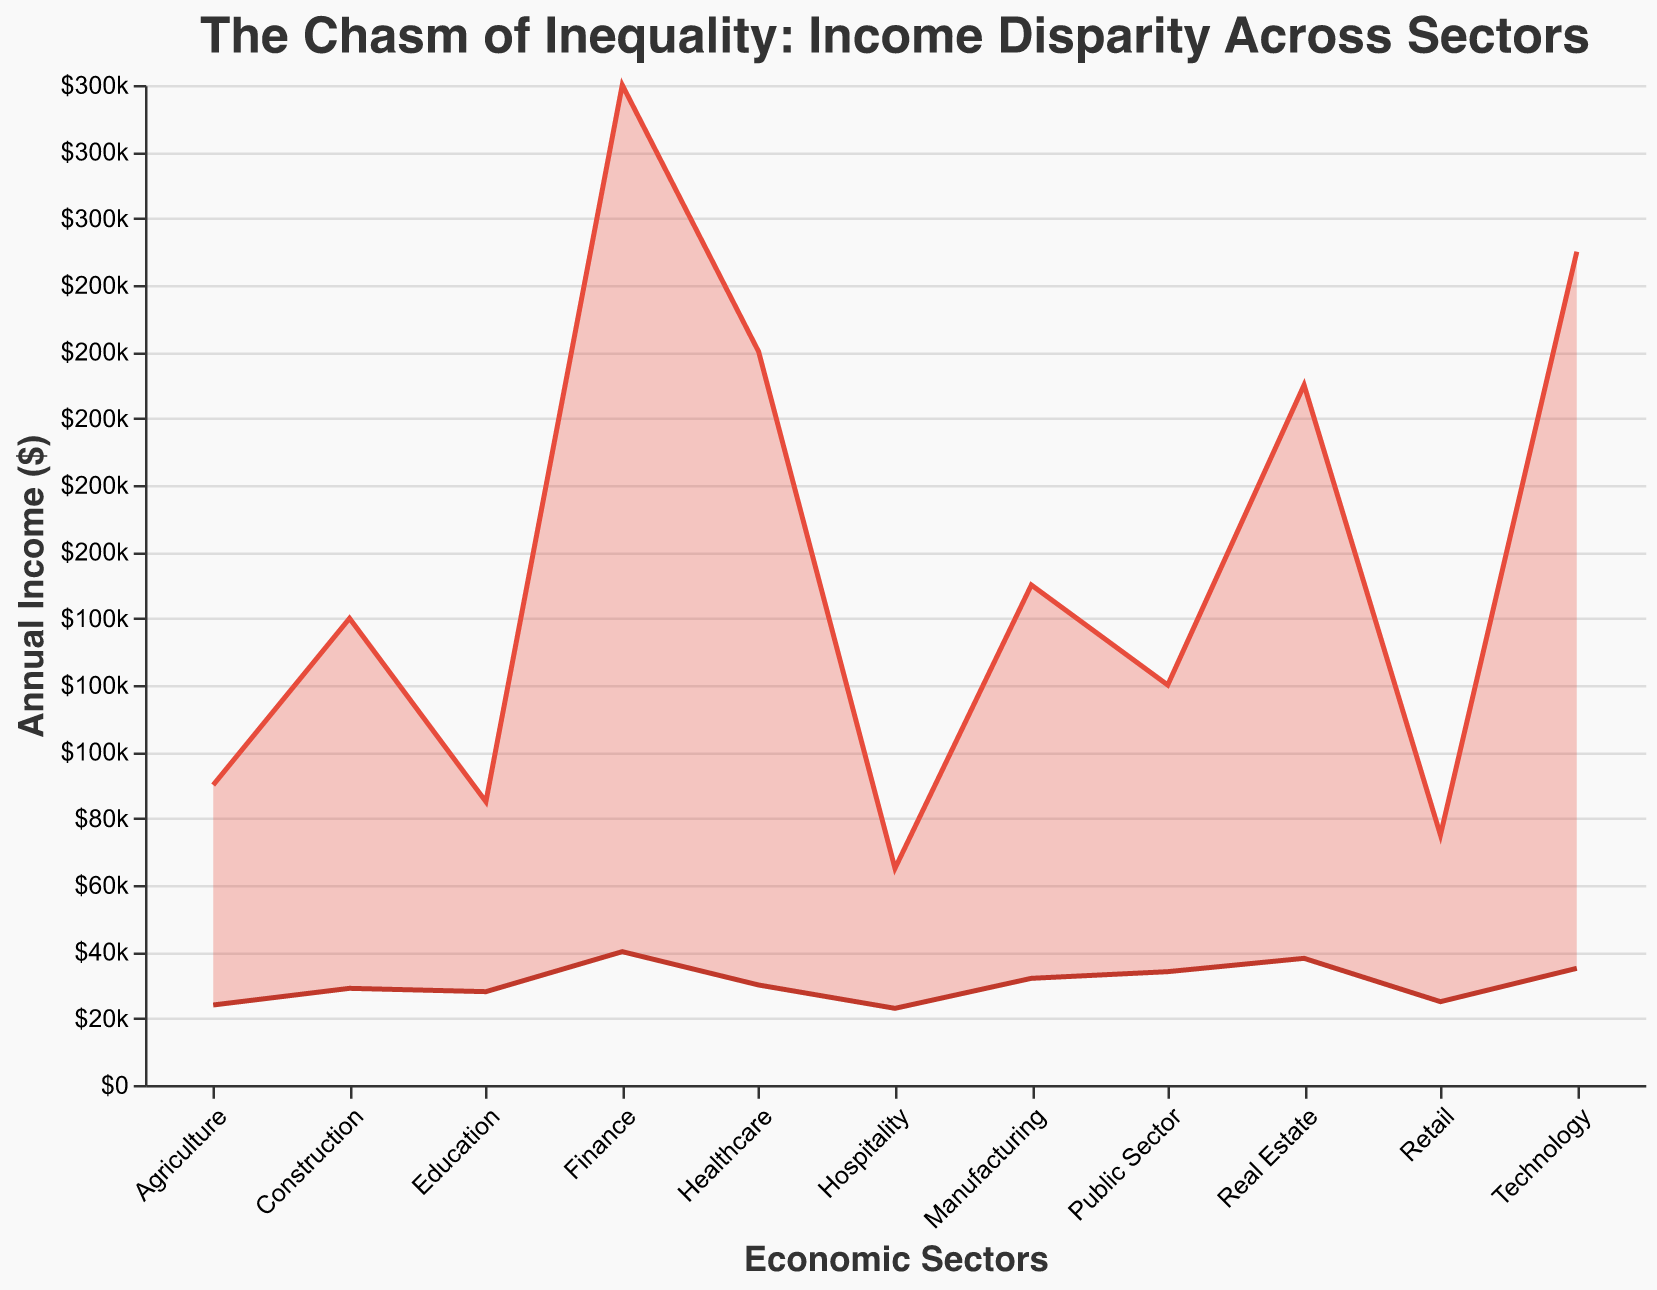What is the median value of the upper percentile income across all sectors? To find the median value, first list the upper percentile incomes: 250000, 220000, 300000, 85000, 150000, 75000, 65000, 140000, 120000, 210000, 90000. Sort them: 65000, 75000, 85000, 90000, 120000, 140000, 150000, 210000, 220000, 250000, 300000. The median is the middle value which is 140000.
Answer: 140000 Which sector has the widest income disparity? The widest income disparity is calculated by finding the difference between upper and lower percentiles for each sector. For Technology, it’s 250000 - 35000 = 215000; for Healthcare, it’s 220000 - 30000 = 190000; for Finance, it’s 300000 - 40000 = 260000, and so on. The widest disparity is in the Finance sector with a difference of 260000.
Answer: Finance Which sectors have the smallest and largest lower percentile incomes? The lower percentile incomes are listed: 35000, 30000, 40000, 28000, 32000, 25000, 23000, 29000, 34000, 38000, 24000. The smallest is the Hospitality sector with 23000, and the largest is the Finance sector with 40000.
Answer: Smallest: Hospitality; Largest: Finance What is the title of the chart? The title of the chart is directly displayed at the top.
Answer: The Chasm of Inequality: Income Disparity Across Sectors Compare the income disparity between Education and Retail sectors. The disparity for Education is 85000 - 28000 = 57000, while for Retail it is 75000 - 25000 = 50000. Education has a larger disparity (57000 vs. 50000).
Answer: Education: 57000, Retail: 50000 How does the income range for Technology compare to that for Retail? The income range for Technology is 250000 - 35000 = 215000, and for Retail it is 75000 - 25000 = 50000. Technology's income range is significantly higher (215000 vs. 50000).
Answer: Technology: 215000, Retail: 50000 Which sector has the lower percentile income closest to the overall median lower percentile income? Calculate the median of lower percentile incomes: 35000, 30000, 40000, 28000, 32000, 25000, 23000, 29000, 34000, 38000, 24000. Sorted: 23000, 24000, 25000, 28000, 29000, 30000, 32000, 34000, 35000, 38000, 40000. Median is 30000. The sector closest to this value is Healthcare with a lower percentile income of 30000.
Answer: Healthcare What is the income range for the Public Sector? Calculate the difference between the upper and lower percentiles for the Public Sector: 120000 - 34000 = 86000.
Answer: 86000 